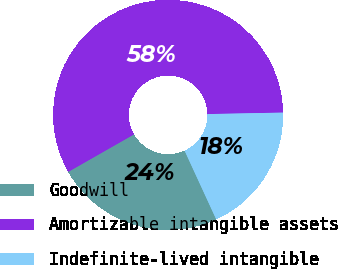<chart> <loc_0><loc_0><loc_500><loc_500><pie_chart><fcel>Goodwill<fcel>Amortizable intangible assets<fcel>Indefinite-lived intangible<nl><fcel>23.62%<fcel>57.93%<fcel>18.45%<nl></chart> 